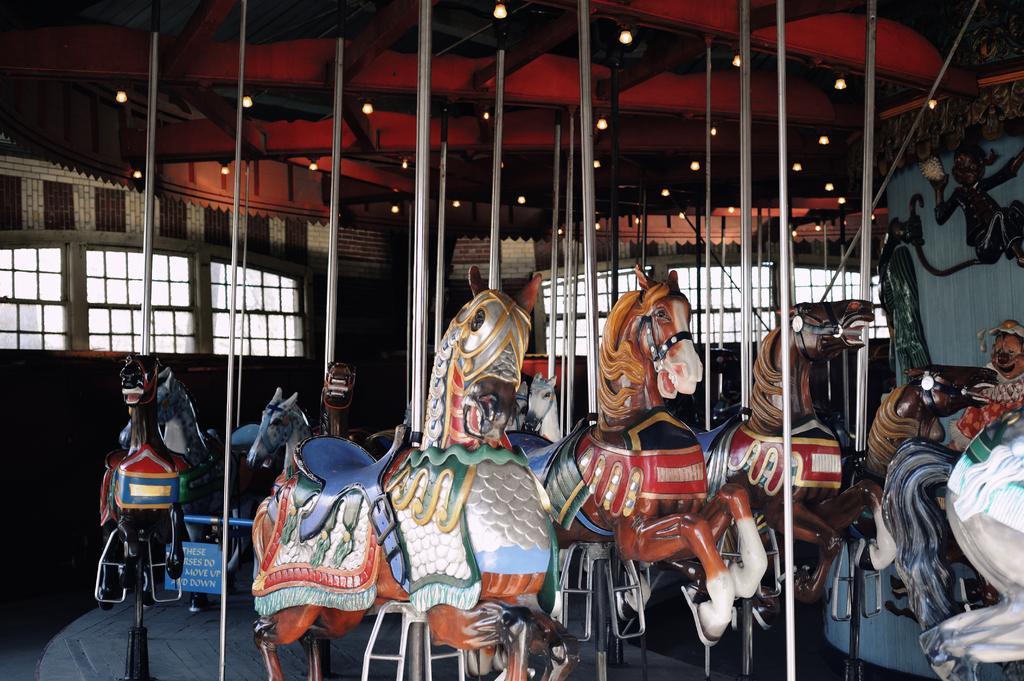Describe this image in one or two sentences. In this image we can see a carousel. In the background there is a wall and we can see windows. At the top there are lights. 